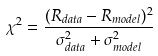<formula> <loc_0><loc_0><loc_500><loc_500>\chi ^ { 2 } = \frac { ( R _ { d a t a } - R _ { m o d e l } ) ^ { 2 } } { \sigma _ { d a t a } ^ { 2 } + \sigma _ { m o d e l } ^ { 2 } }</formula> 